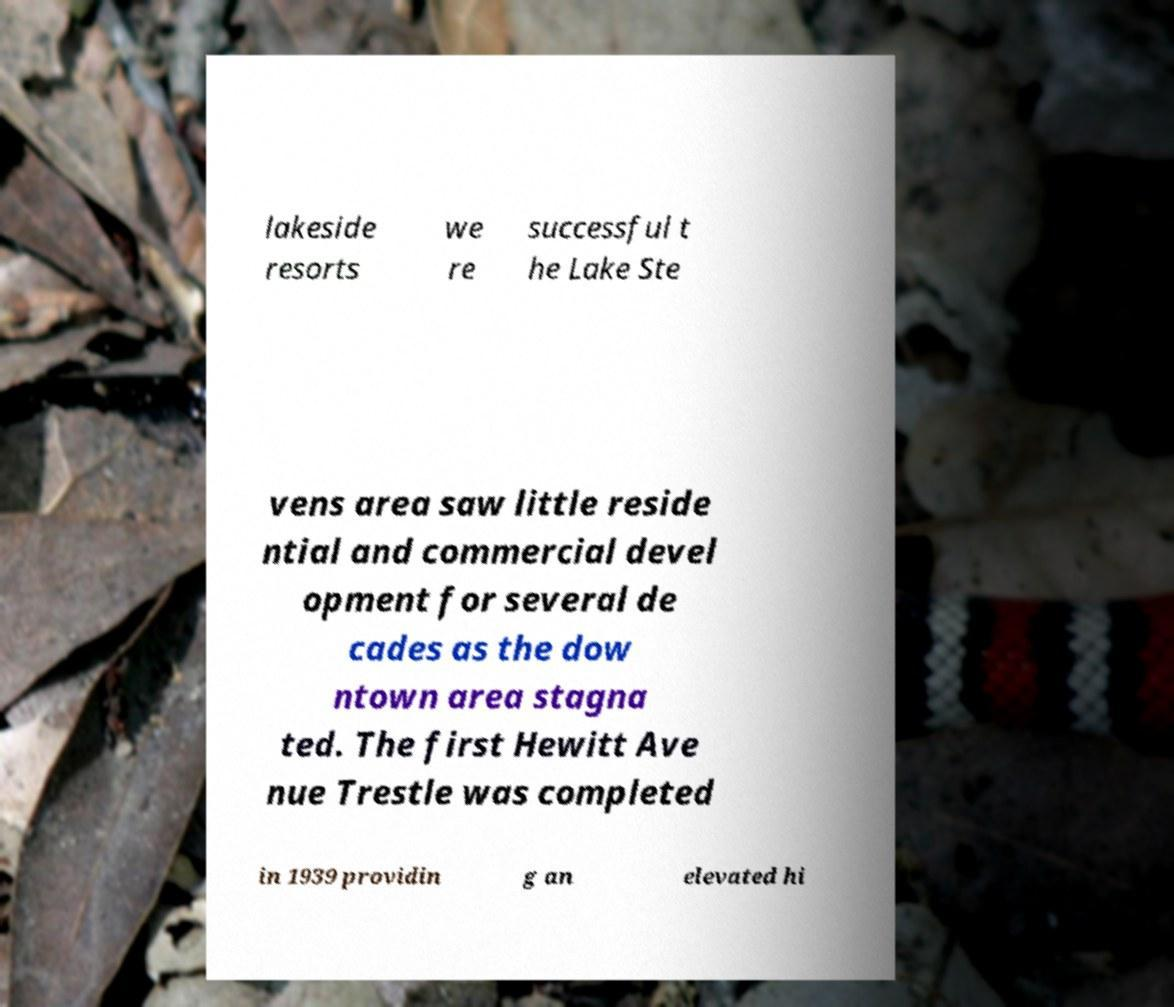What messages or text are displayed in this image? I need them in a readable, typed format. lakeside resorts we re successful t he Lake Ste vens area saw little reside ntial and commercial devel opment for several de cades as the dow ntown area stagna ted. The first Hewitt Ave nue Trestle was completed in 1939 providin g an elevated hi 